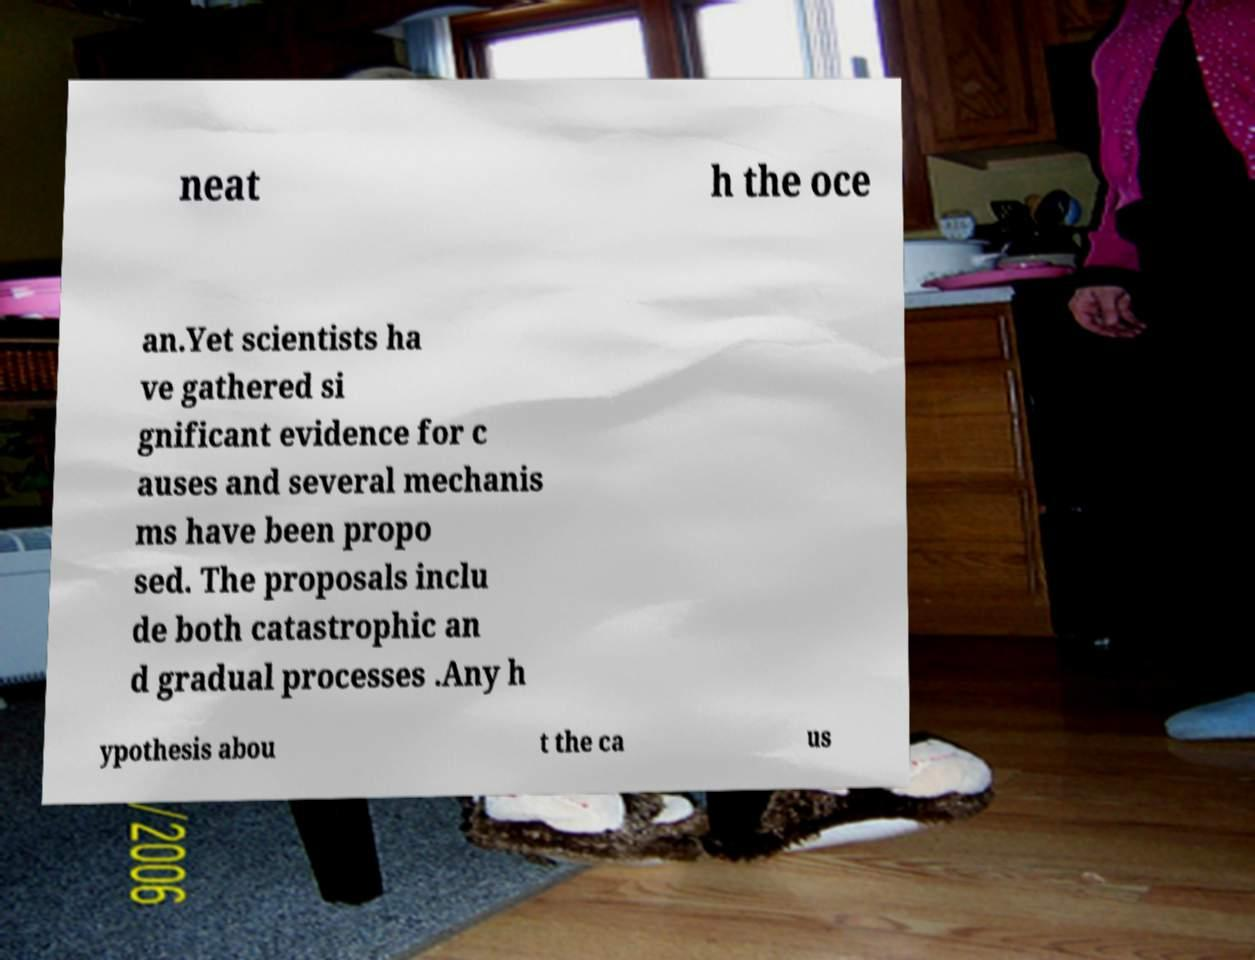Please identify and transcribe the text found in this image. neat h the oce an.Yet scientists ha ve gathered si gnificant evidence for c auses and several mechanis ms have been propo sed. The proposals inclu de both catastrophic an d gradual processes .Any h ypothesis abou t the ca us 